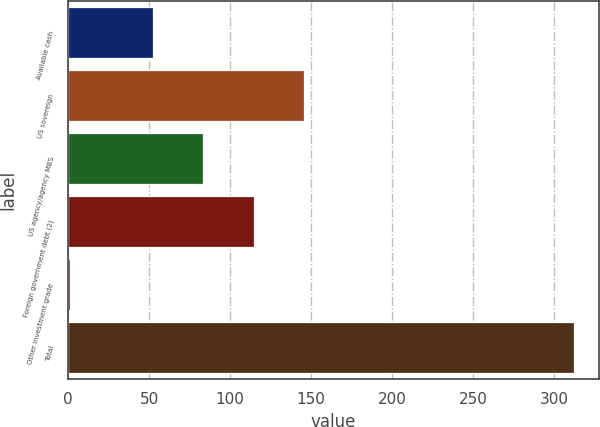<chart> <loc_0><loc_0><loc_500><loc_500><bar_chart><fcel>Available cash<fcel>US sovereign<fcel>US agency/agency MBS<fcel>Foreign government debt (2)<fcel>Other investment grade<fcel>Total<nl><fcel>52.4<fcel>145.73<fcel>83.51<fcel>114.62<fcel>1<fcel>312.1<nl></chart> 